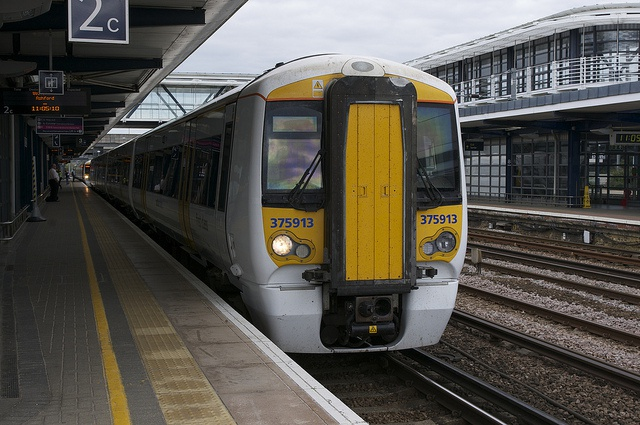Describe the objects in this image and their specific colors. I can see a train in black, gray, olive, and darkgray tones in this image. 